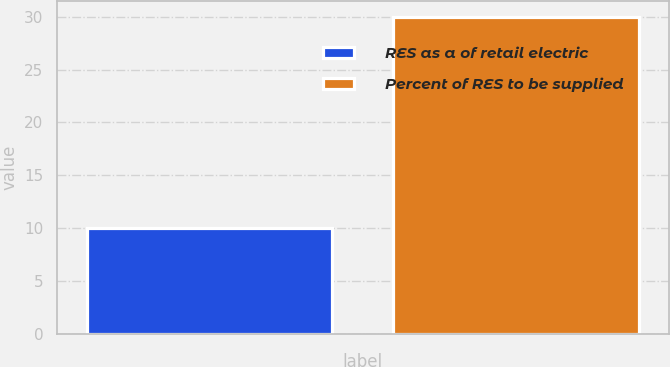Convert chart to OTSL. <chart><loc_0><loc_0><loc_500><loc_500><bar_chart><fcel>RES as a of retail electric<fcel>Percent of RES to be supplied<nl><fcel>10<fcel>30<nl></chart> 